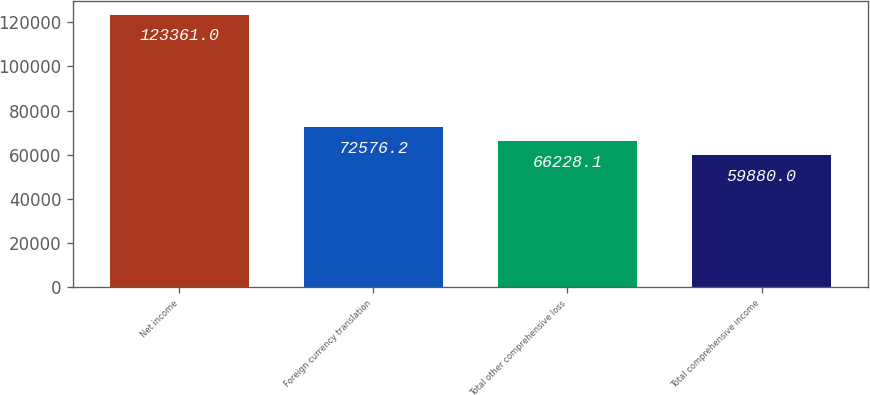Convert chart. <chart><loc_0><loc_0><loc_500><loc_500><bar_chart><fcel>Net income<fcel>Foreign currency translation<fcel>Total other comprehensive loss<fcel>Total comprehensive income<nl><fcel>123361<fcel>72576.2<fcel>66228.1<fcel>59880<nl></chart> 